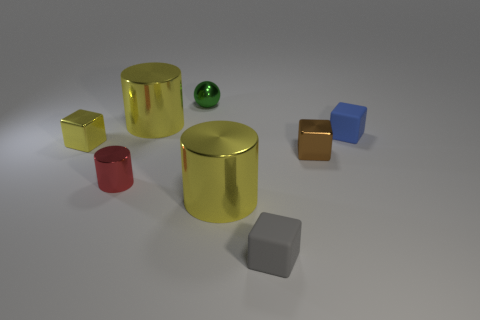What number of balls are either tiny gray rubber things or large purple metallic things? In the image, there are no balls that meet the criteria of being either tiny gray rubber items or large purple metallic objects. Instead, we can see one small green ball, along with various other colored geometric solids, none of which are purple or gray. 